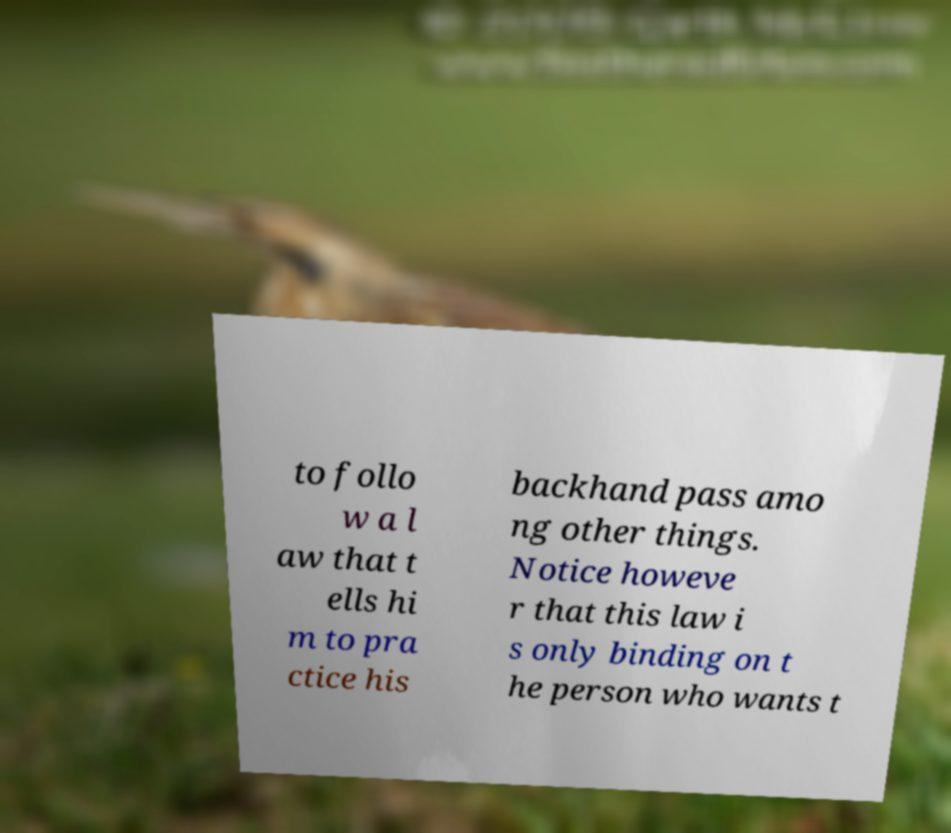Can you accurately transcribe the text from the provided image for me? to follo w a l aw that t ells hi m to pra ctice his backhand pass amo ng other things. Notice howeve r that this law i s only binding on t he person who wants t 